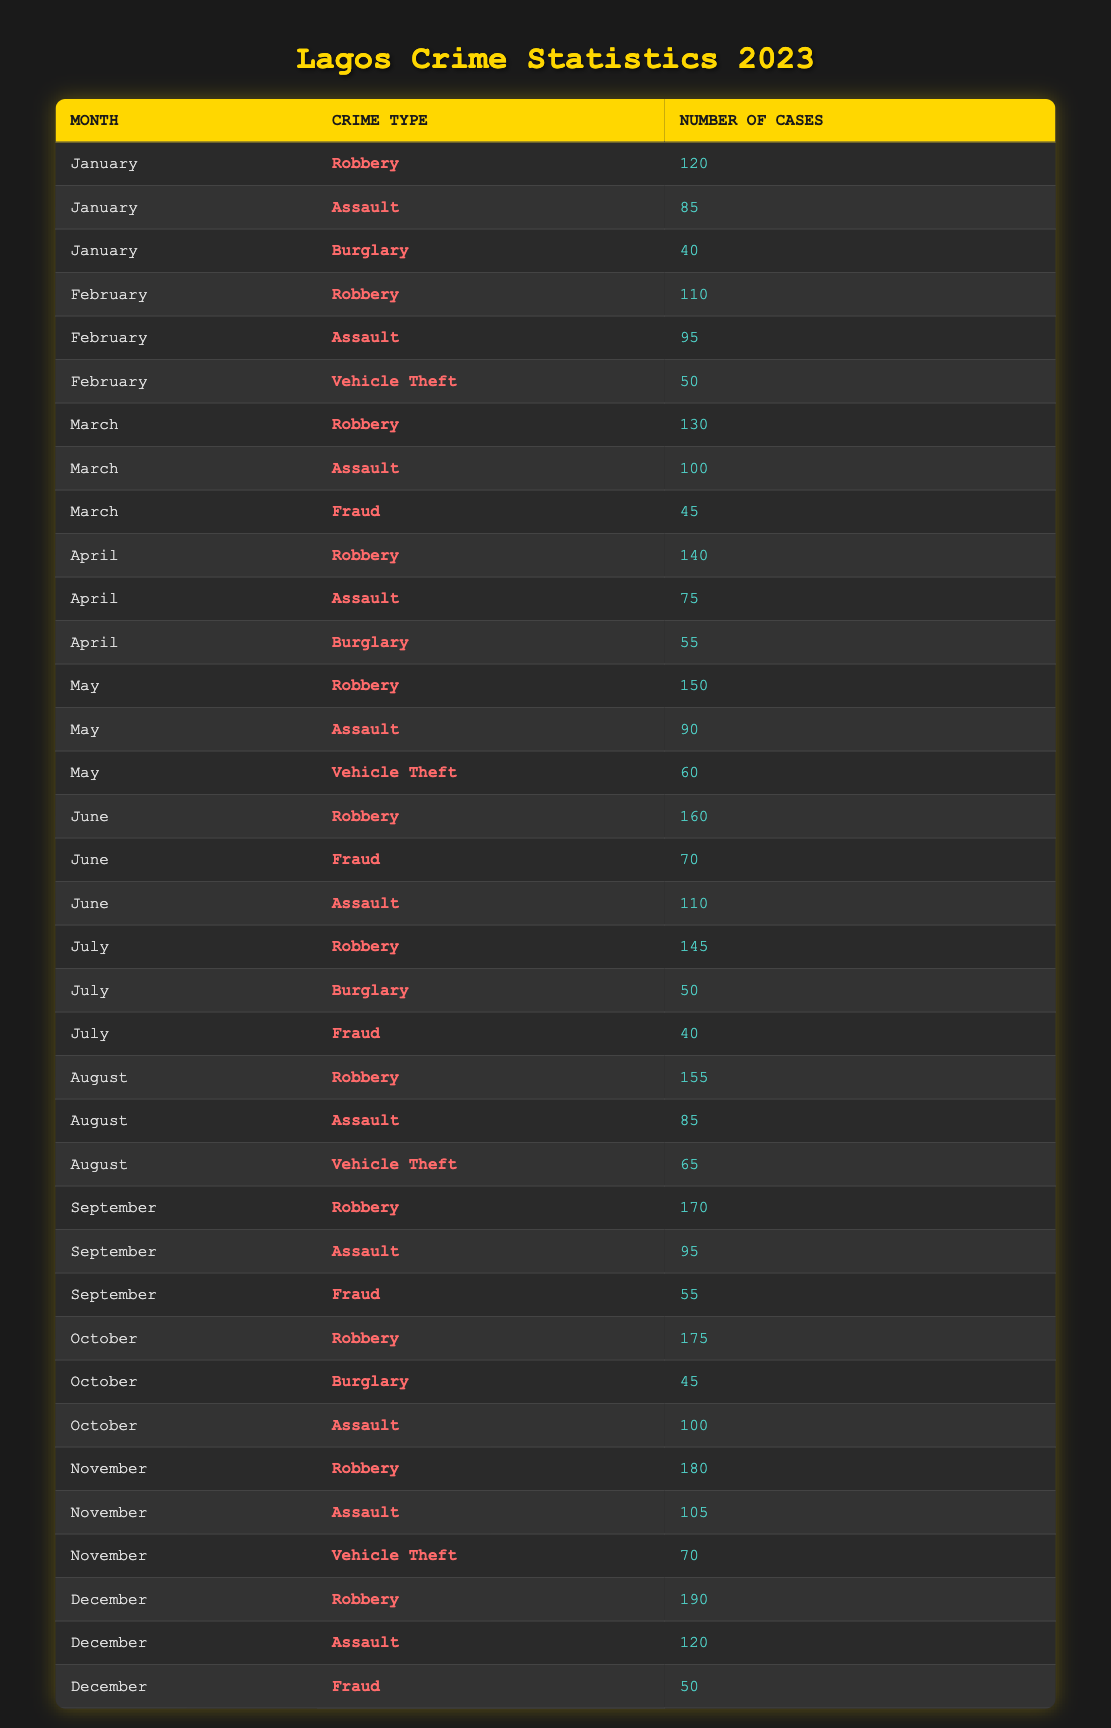What is the total number of robbery cases reported in June and July? From the table, in June there were 160 robbery cases and in July there were 145 robbery cases. Adding these values gives us 160 + 145 = 305.
Answer: 305 How many cases of assault were reported in November? November has one entry for assault which shows there were 105 cases.
Answer: 105 Which month had the highest number of vehicle theft cases? Reviewing the table, the only months with vehicle theft cases are February (50 cases), May (60 cases), August (65 cases), and November (70 cases). The month with the highest number is November with 70 cases.
Answer: November Did the number of burglary cases increase from January to April? In January there were 40 burglary cases, while in April there were 55 cases. Since 55 is greater than 40, this means there was an increase in burglary cases over that time.
Answer: Yes What is the average number of robbery cases reported each month from January to August? The total robbery cases from January (120), February (110), March (130), April (140), May (150), June (160), July (145), and August (155) amounts to 1,110. There are 8 months, so the average is 1,110 / 8 = 138.75.
Answer: 138.75 In which month did robbery cases peak, and what was the number? The highest number of robbery cases recorded is in December, with 190 cases according to the table.
Answer: December, 190 How many total assault cases were reported between February and March? In February, there were 95 assault cases and in March, there were 100 cases. Adding them results in 95 + 100 = 195 assault cases total in those two months.
Answer: 195 Are there more than 150 robbery cases reported in September? Looking at September, it shows 170 robbery cases, which is indeed more than 150.
Answer: Yes What is the difference between the highest and lowest number of assault cases reported in 2023? The highest number of assault cases is in December (120 cases), and the lowest is in April (75 cases). The difference is 120 - 75 = 45.
Answer: 45 